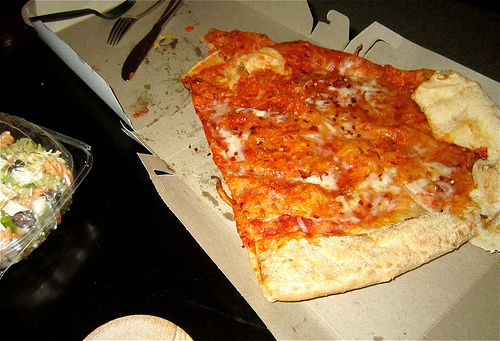What type of food is shown in the image? The image features a large slice of cheese pizza on a cardboard takeout box and a small salad in a clear plastic container. 